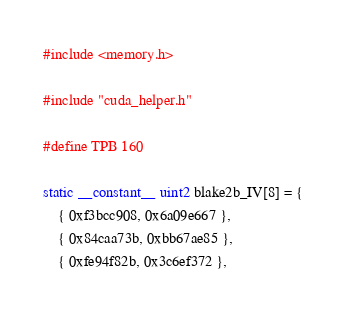Convert code to text. <code><loc_0><loc_0><loc_500><loc_500><_Cuda_>#include <memory.h>

#include "cuda_helper.h"

#define TPB 160

static __constant__ uint2 blake2b_IV[8] = {
	{ 0xf3bcc908, 0x6a09e667 },
	{ 0x84caa73b, 0xbb67ae85 },
	{ 0xfe94f82b, 0x3c6ef372 },</code> 